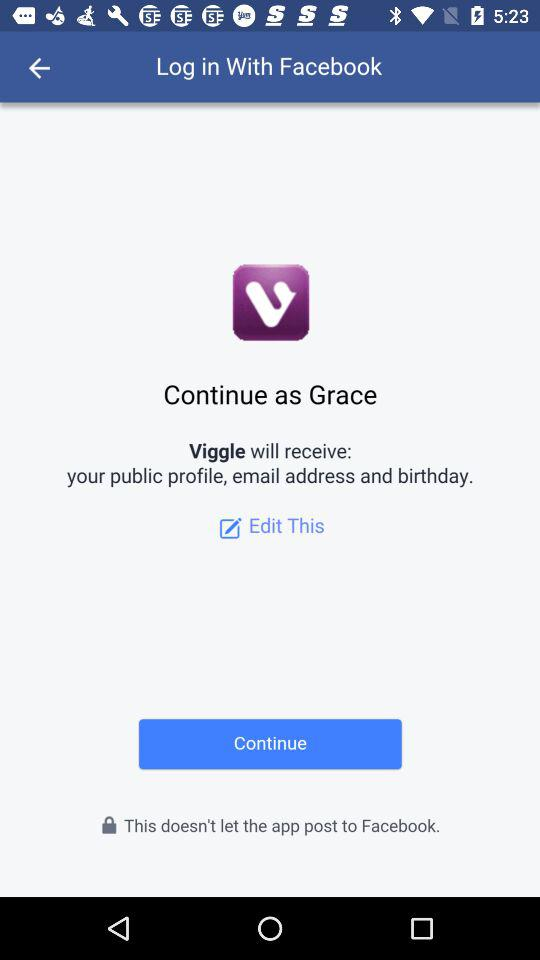What application is asking for permission? The application is "Viggle". 